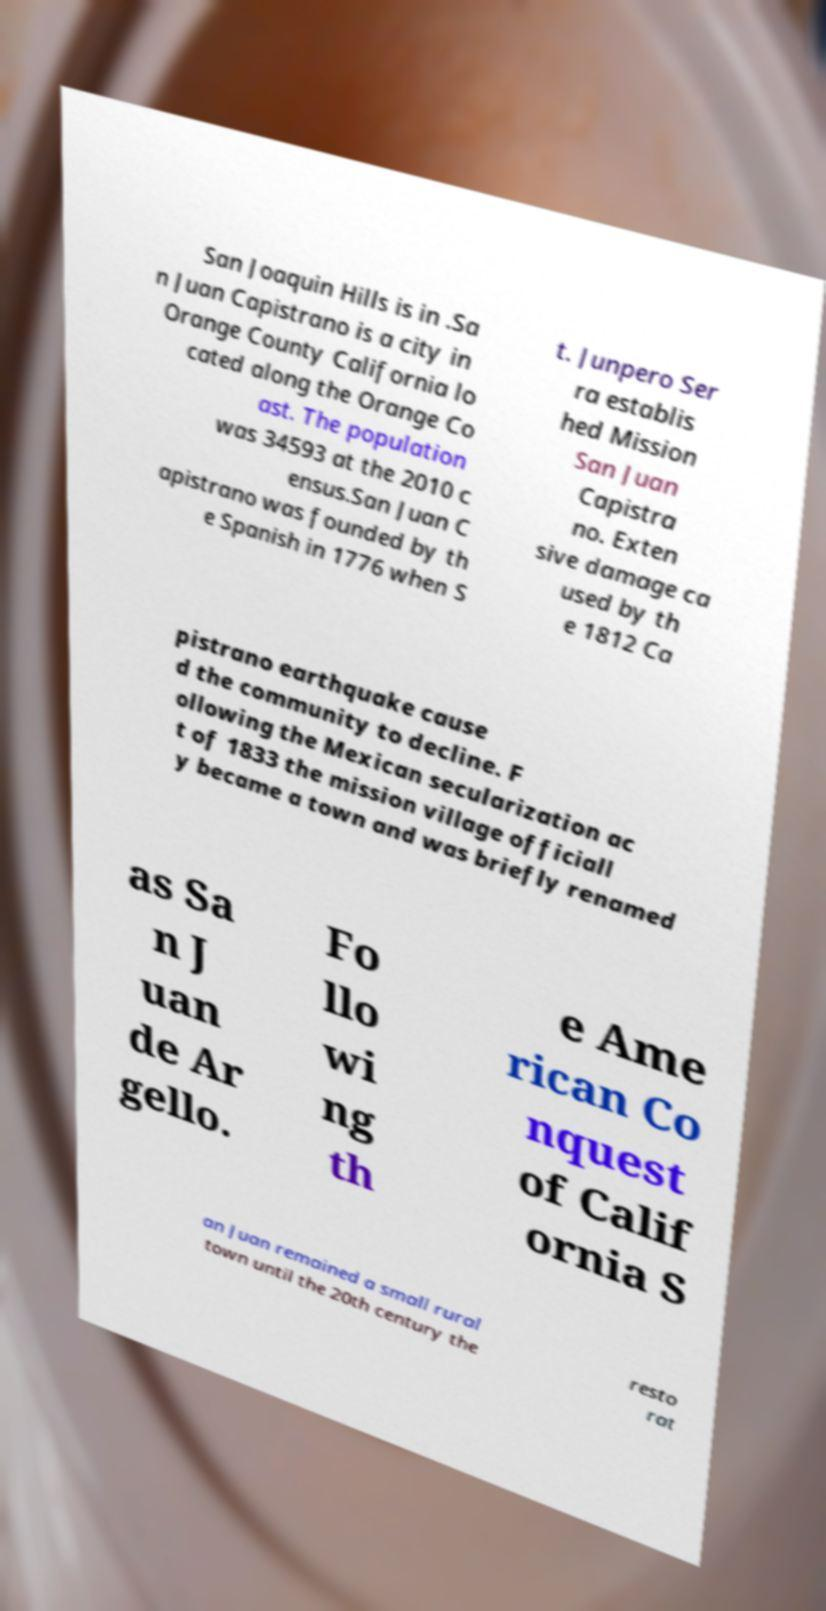There's text embedded in this image that I need extracted. Can you transcribe it verbatim? San Joaquin Hills is in .Sa n Juan Capistrano is a city in Orange County California lo cated along the Orange Co ast. The population was 34593 at the 2010 c ensus.San Juan C apistrano was founded by th e Spanish in 1776 when S t. Junpero Ser ra establis hed Mission San Juan Capistra no. Exten sive damage ca used by th e 1812 Ca pistrano earthquake cause d the community to decline. F ollowing the Mexican secularization ac t of 1833 the mission village officiall y became a town and was briefly renamed as Sa n J uan de Ar gello. Fo llo wi ng th e Ame rican Co nquest of Calif ornia S an Juan remained a small rural town until the 20th century the resto rat 